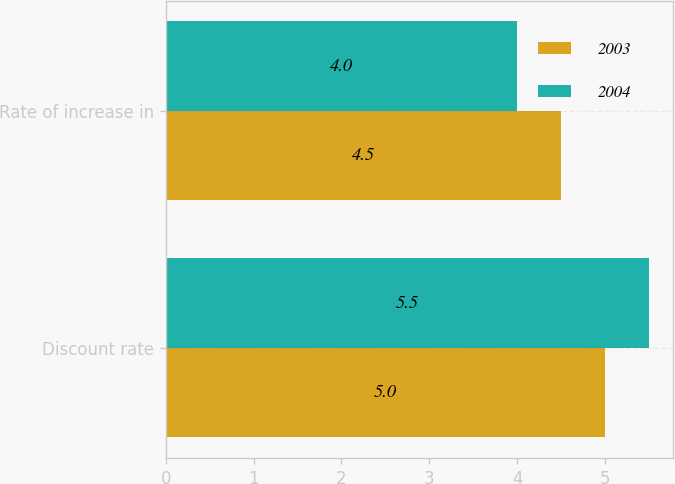Convert chart. <chart><loc_0><loc_0><loc_500><loc_500><stacked_bar_chart><ecel><fcel>Discount rate<fcel>Rate of increase in<nl><fcel>2003<fcel>5<fcel>4.5<nl><fcel>2004<fcel>5.5<fcel>4<nl></chart> 